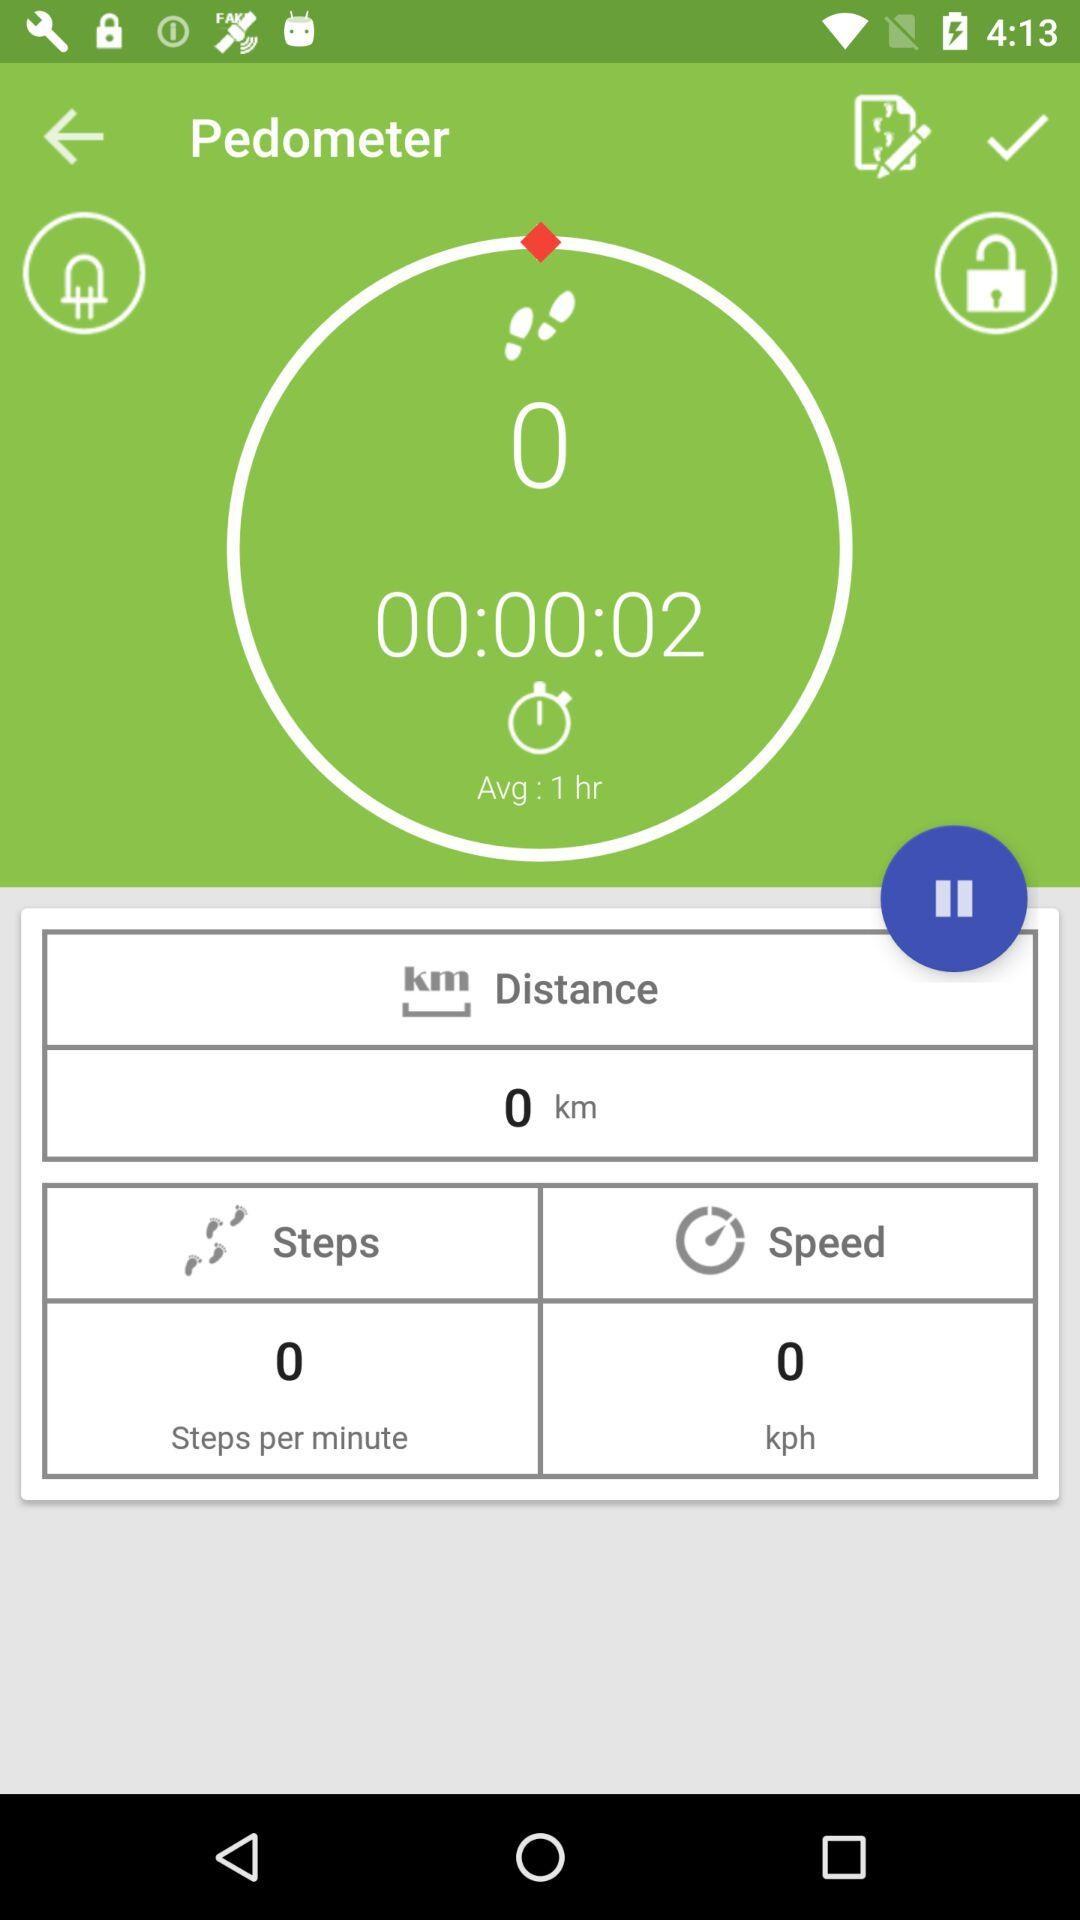What is the unit of distance? The unit of distance is km. 